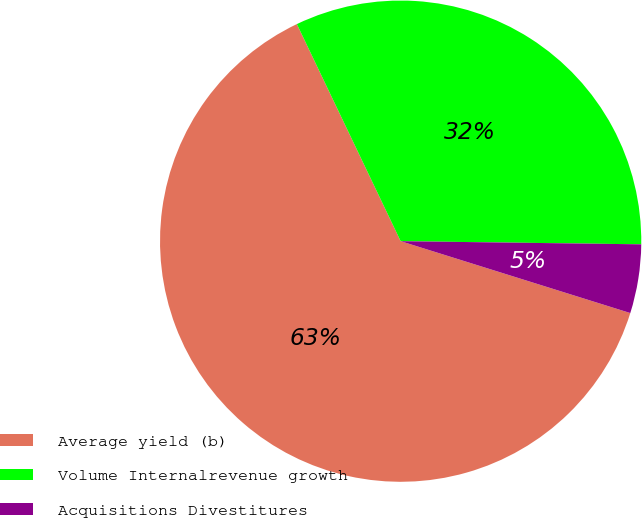Convert chart. <chart><loc_0><loc_0><loc_500><loc_500><pie_chart><fcel>Average yield (b)<fcel>Volume Internalrevenue growth<fcel>Acquisitions Divestitures<nl><fcel>63.08%<fcel>32.31%<fcel>4.62%<nl></chart> 